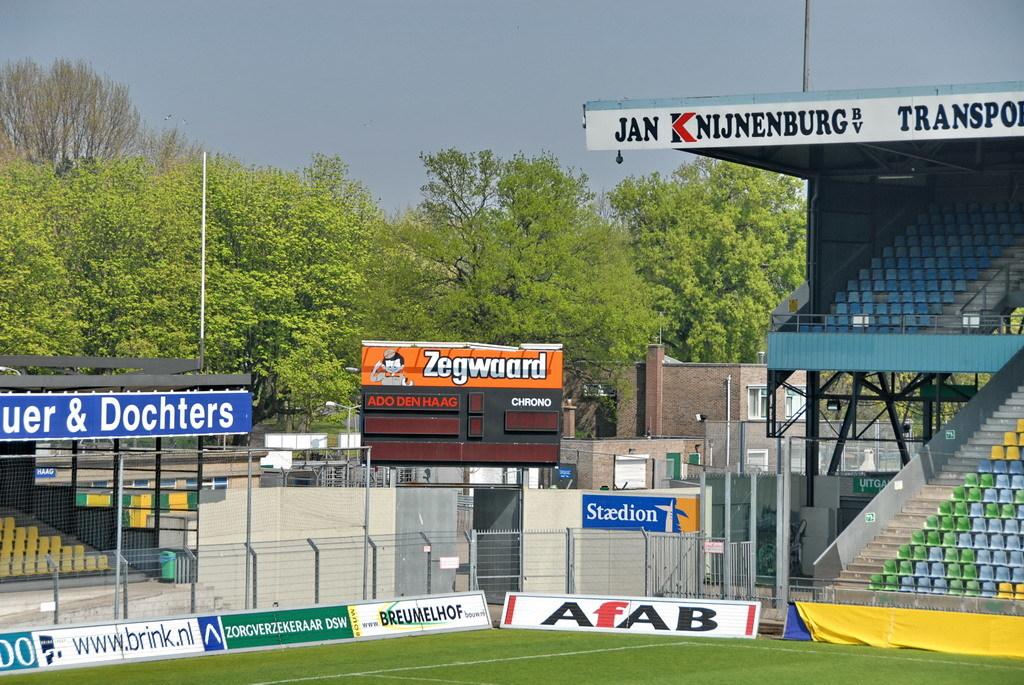What word is displayed on the orange sign?
Provide a succinct answer. Zegwaard. What letter is red?
Your answer should be compact. F. 